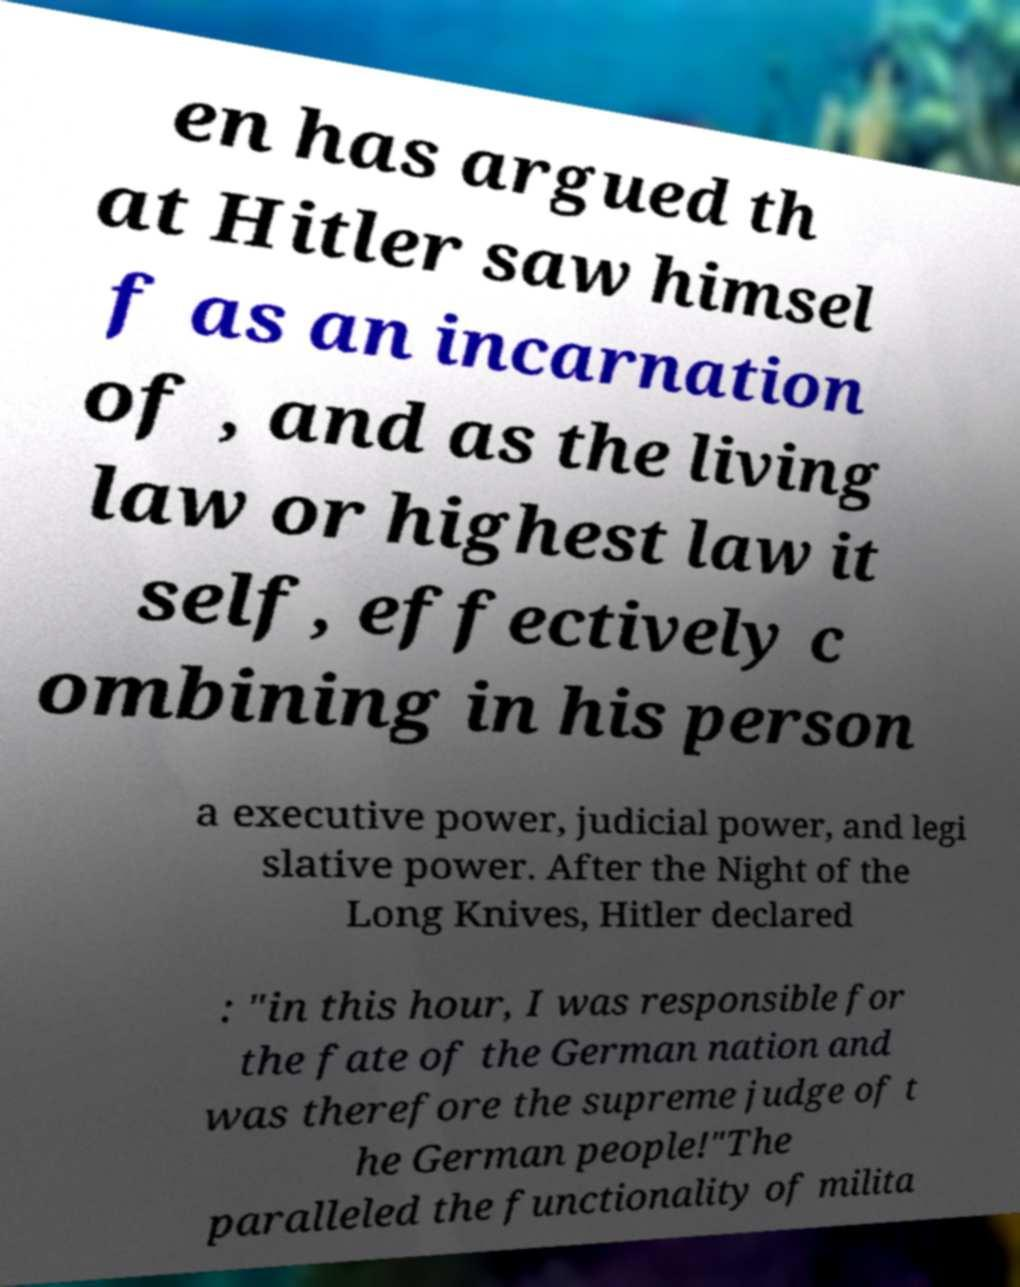Could you extract and type out the text from this image? en has argued th at Hitler saw himsel f as an incarnation of , and as the living law or highest law it self, effectively c ombining in his person a executive power, judicial power, and legi slative power. After the Night of the Long Knives, Hitler declared : "in this hour, I was responsible for the fate of the German nation and was therefore the supreme judge of t he German people!"The paralleled the functionality of milita 